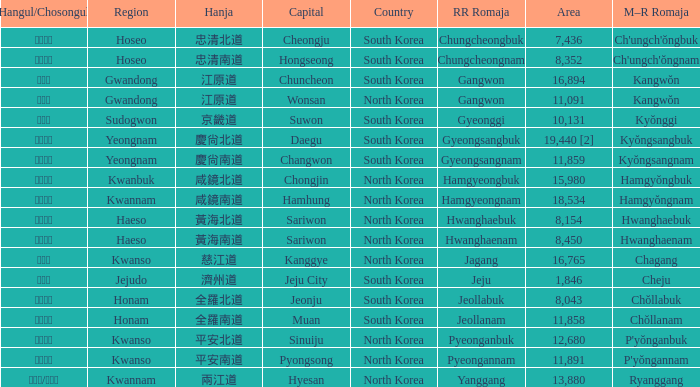What is the area for the province having Hangul of 경기도? 10131.0. 